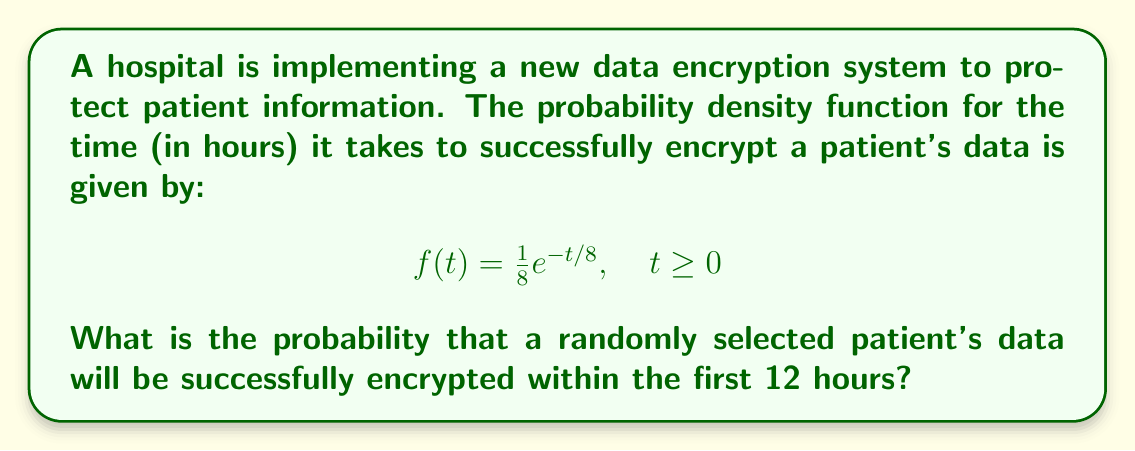Solve this math problem. To solve this problem, we need to integrate the probability density function over the interval [0, 12]. This will give us the cumulative probability of successful encryption within the first 12 hours.

The probability is given by:

$$P(0 \leq T \leq 12) = \int_0^{12} f(t) dt$$

Substituting the given function:

$$P(0 \leq T \leq 12) = \int_0^{12} \frac{1}{8}e^{-t/8} dt$$

To solve this integral, we can use the substitution method:

Let $u = -t/8$, then $du = -\frac{1}{8}dt$
When $t = 0$, $u = 0$
When $t = 12$, $u = -3/2$

Rewriting the integral:

$$P(0 \leq T \leq 12) = \int_{0}^{-3/2} e^u (-8du) = -8\int_{0}^{-3/2} e^u du$$

Evaluating the integral:

$$P(0 \leq T \leq 12) = -8[e^u]_{0}^{-3/2} = -8(e^{-3/2} - e^0) = -8(e^{-3/2} - 1)$$

$$= 8(1 - e^{-3/2})$$

$$\approx 0.7769 \text{ or } 77.69\%$$
Answer: The probability that a randomly selected patient's data will be successfully encrypted within the first 12 hours is approximately 0.7769 or 77.69%. 